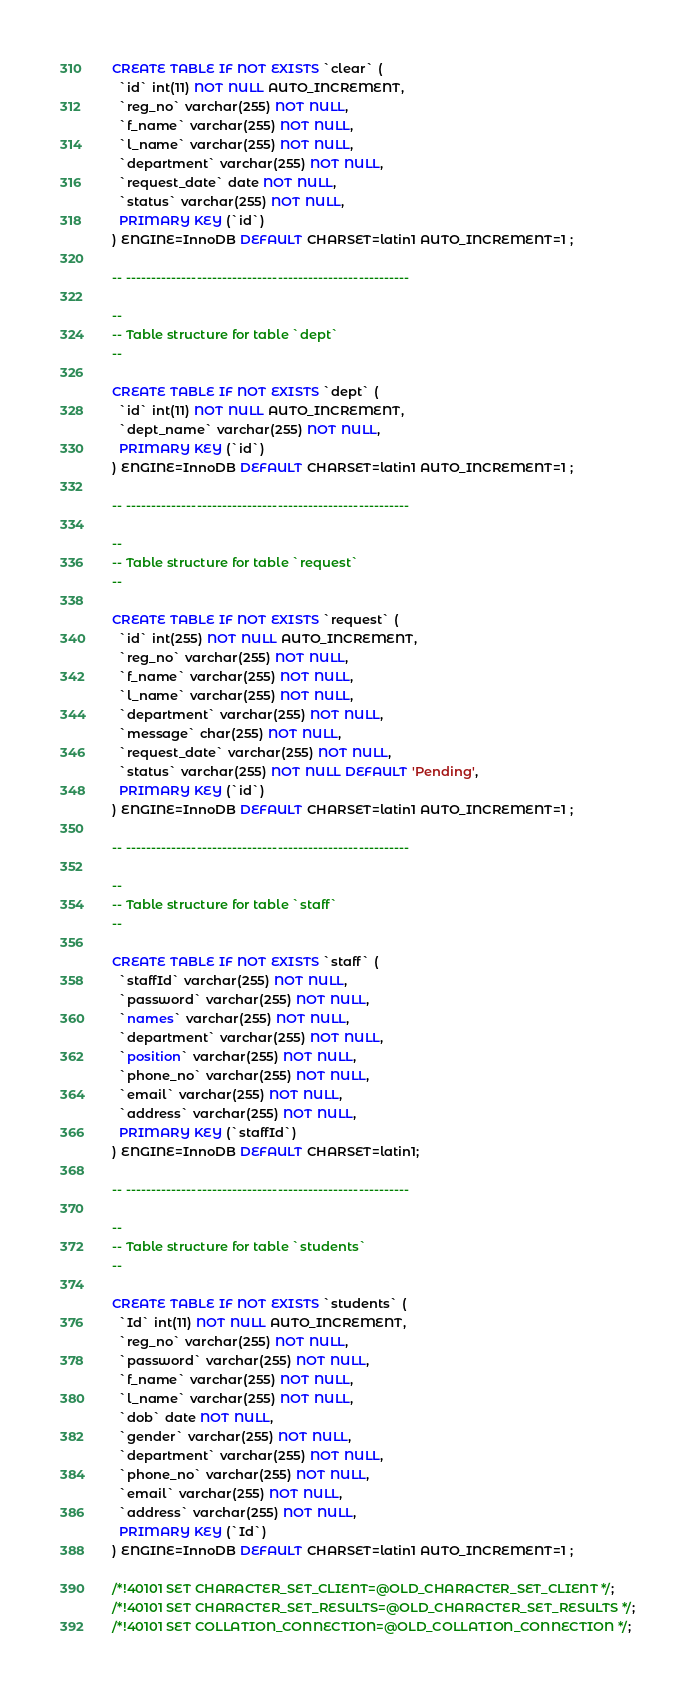Convert code to text. <code><loc_0><loc_0><loc_500><loc_500><_SQL_>CREATE TABLE IF NOT EXISTS `clear` (
  `id` int(11) NOT NULL AUTO_INCREMENT,
  `reg_no` varchar(255) NOT NULL,
  `f_name` varchar(255) NOT NULL,
  `l_name` varchar(255) NOT NULL,
  `department` varchar(255) NOT NULL,
  `request_date` date NOT NULL,
  `status` varchar(255) NOT NULL,
  PRIMARY KEY (`id`)
) ENGINE=InnoDB DEFAULT CHARSET=latin1 AUTO_INCREMENT=1 ;

-- --------------------------------------------------------

--
-- Table structure for table `dept`
--

CREATE TABLE IF NOT EXISTS `dept` (
  `id` int(11) NOT NULL AUTO_INCREMENT,
  `dept_name` varchar(255) NOT NULL,
  PRIMARY KEY (`id`)
) ENGINE=InnoDB DEFAULT CHARSET=latin1 AUTO_INCREMENT=1 ;

-- --------------------------------------------------------

--
-- Table structure for table `request`
--

CREATE TABLE IF NOT EXISTS `request` (
  `id` int(255) NOT NULL AUTO_INCREMENT,
  `reg_no` varchar(255) NOT NULL,
  `f_name` varchar(255) NOT NULL,
  `l_name` varchar(255) NOT NULL,
  `department` varchar(255) NOT NULL,
  `message` char(255) NOT NULL,
  `request_date` varchar(255) NOT NULL,
  `status` varchar(255) NOT NULL DEFAULT 'Pending',
  PRIMARY KEY (`id`)
) ENGINE=InnoDB DEFAULT CHARSET=latin1 AUTO_INCREMENT=1 ;

-- --------------------------------------------------------

--
-- Table structure for table `staff`
--

CREATE TABLE IF NOT EXISTS `staff` (
  `staffId` varchar(255) NOT NULL,
  `password` varchar(255) NOT NULL,
  `names` varchar(255) NOT NULL,
  `department` varchar(255) NOT NULL,
  `position` varchar(255) NOT NULL,
  `phone_no` varchar(255) NOT NULL,
  `email` varchar(255) NOT NULL,
  `address` varchar(255) NOT NULL,
  PRIMARY KEY (`staffId`)
) ENGINE=InnoDB DEFAULT CHARSET=latin1;

-- --------------------------------------------------------

--
-- Table structure for table `students`
--

CREATE TABLE IF NOT EXISTS `students` (
  `Id` int(11) NOT NULL AUTO_INCREMENT,
  `reg_no` varchar(255) NOT NULL,
  `password` varchar(255) NOT NULL,
  `f_name` varchar(255) NOT NULL,
  `l_name` varchar(255) NOT NULL,
  `dob` date NOT NULL,
  `gender` varchar(255) NOT NULL,
  `department` varchar(255) NOT NULL,
  `phone_no` varchar(255) NOT NULL,
  `email` varchar(255) NOT NULL,
  `address` varchar(255) NOT NULL,
  PRIMARY KEY (`Id`)
) ENGINE=InnoDB DEFAULT CHARSET=latin1 AUTO_INCREMENT=1 ;

/*!40101 SET CHARACTER_SET_CLIENT=@OLD_CHARACTER_SET_CLIENT */;
/*!40101 SET CHARACTER_SET_RESULTS=@OLD_CHARACTER_SET_RESULTS */;
/*!40101 SET COLLATION_CONNECTION=@OLD_COLLATION_CONNECTION */;
</code> 